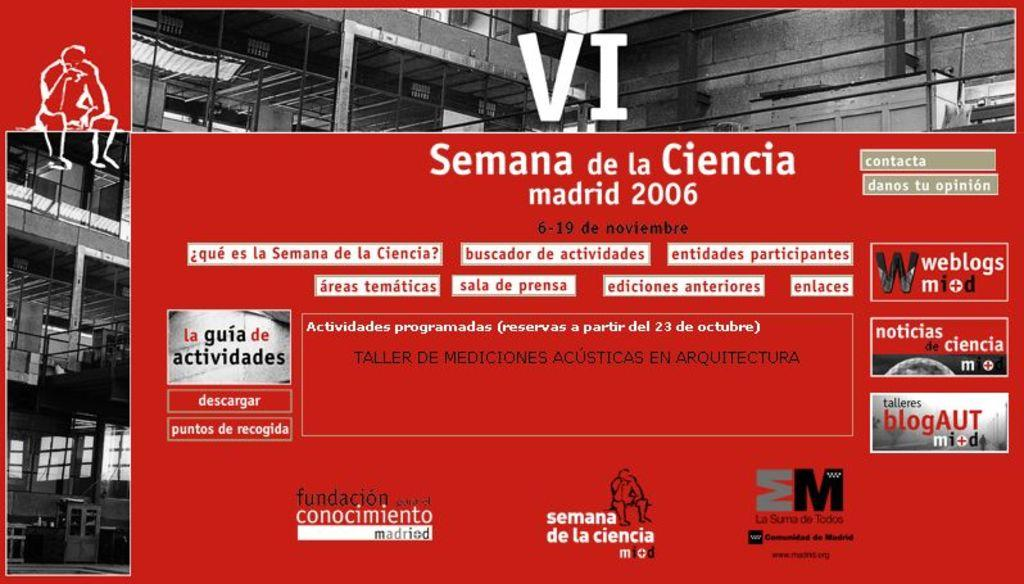Provide a one-sentence caption for the provided image. A flyer for an event in Madrid in 2006. 